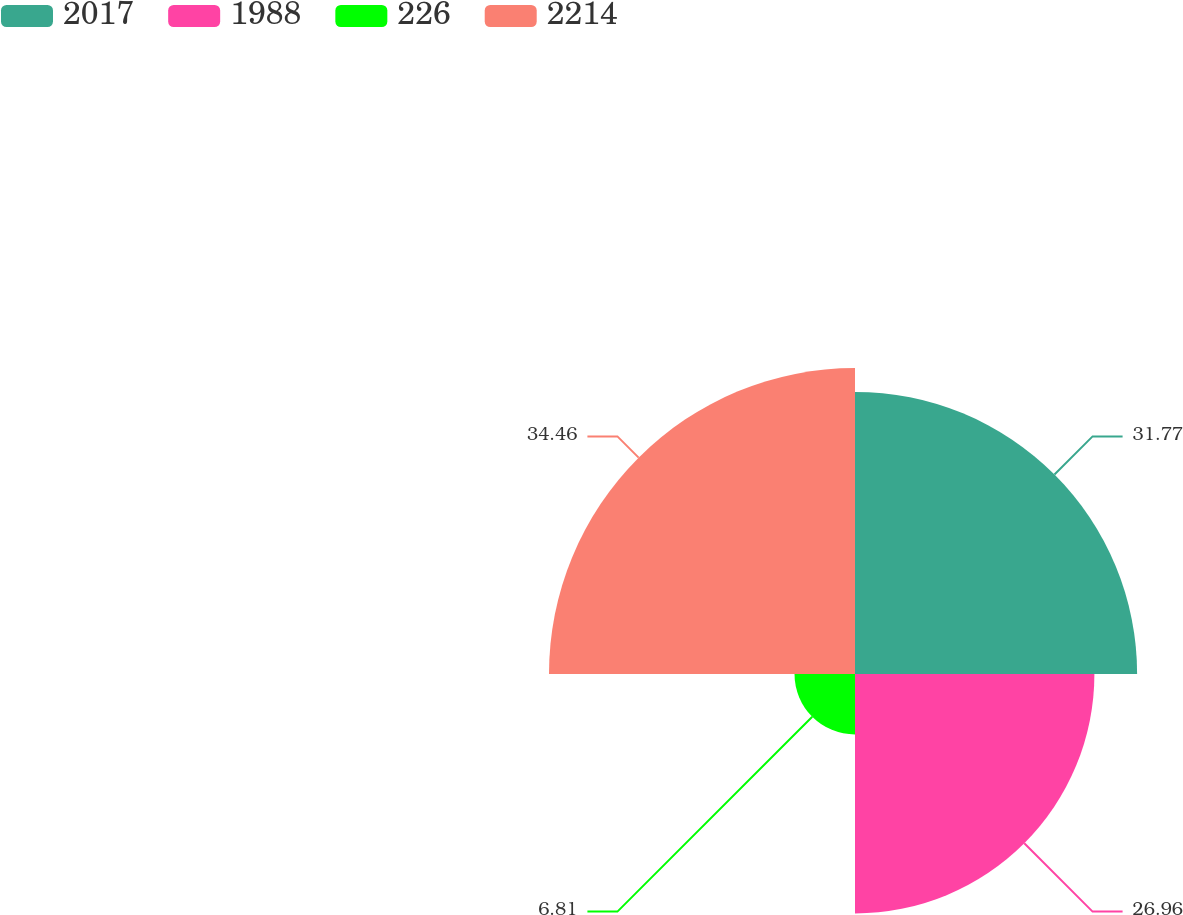Convert chart to OTSL. <chart><loc_0><loc_0><loc_500><loc_500><pie_chart><fcel>2017<fcel>1988<fcel>226<fcel>2214<nl><fcel>31.77%<fcel>26.96%<fcel>6.81%<fcel>34.46%<nl></chart> 